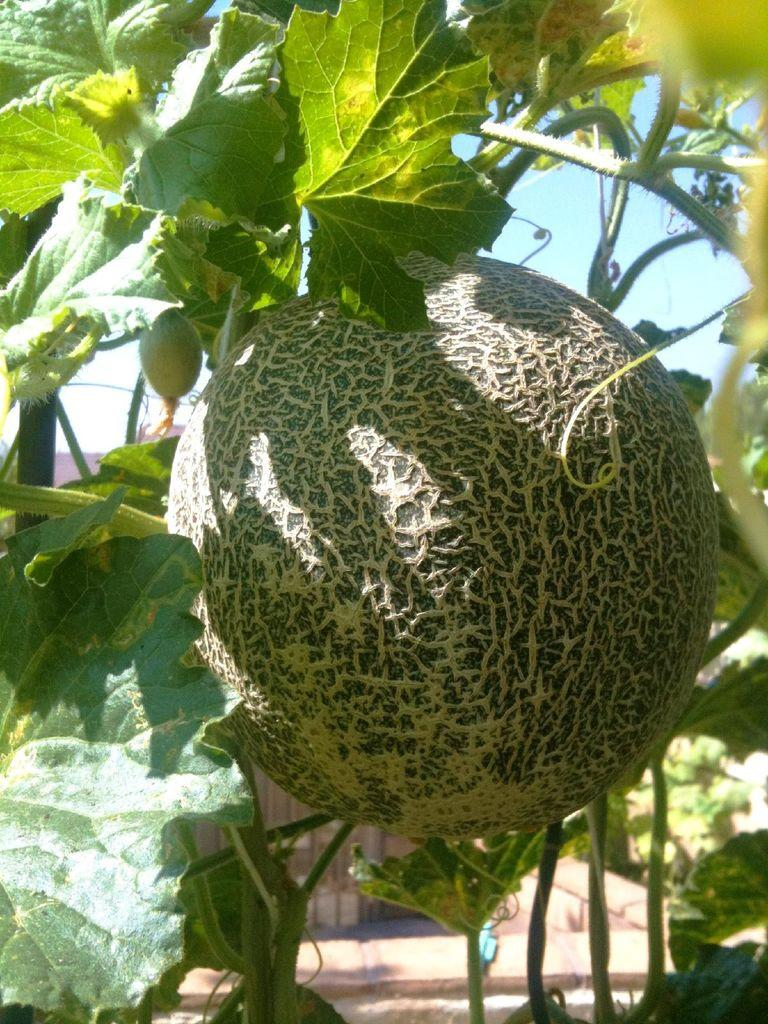What is present on the tree in the image? There are things on a tree in the image. What can be seen in the background of the image? The sky is visible in the background of the image. What type of glass is being used to swim in the image? There is no glass or swimming activity present in the image. What type of beef is hanging from the tree in the image? There is no beef present in the image; it only mentions "things" on the tree. 